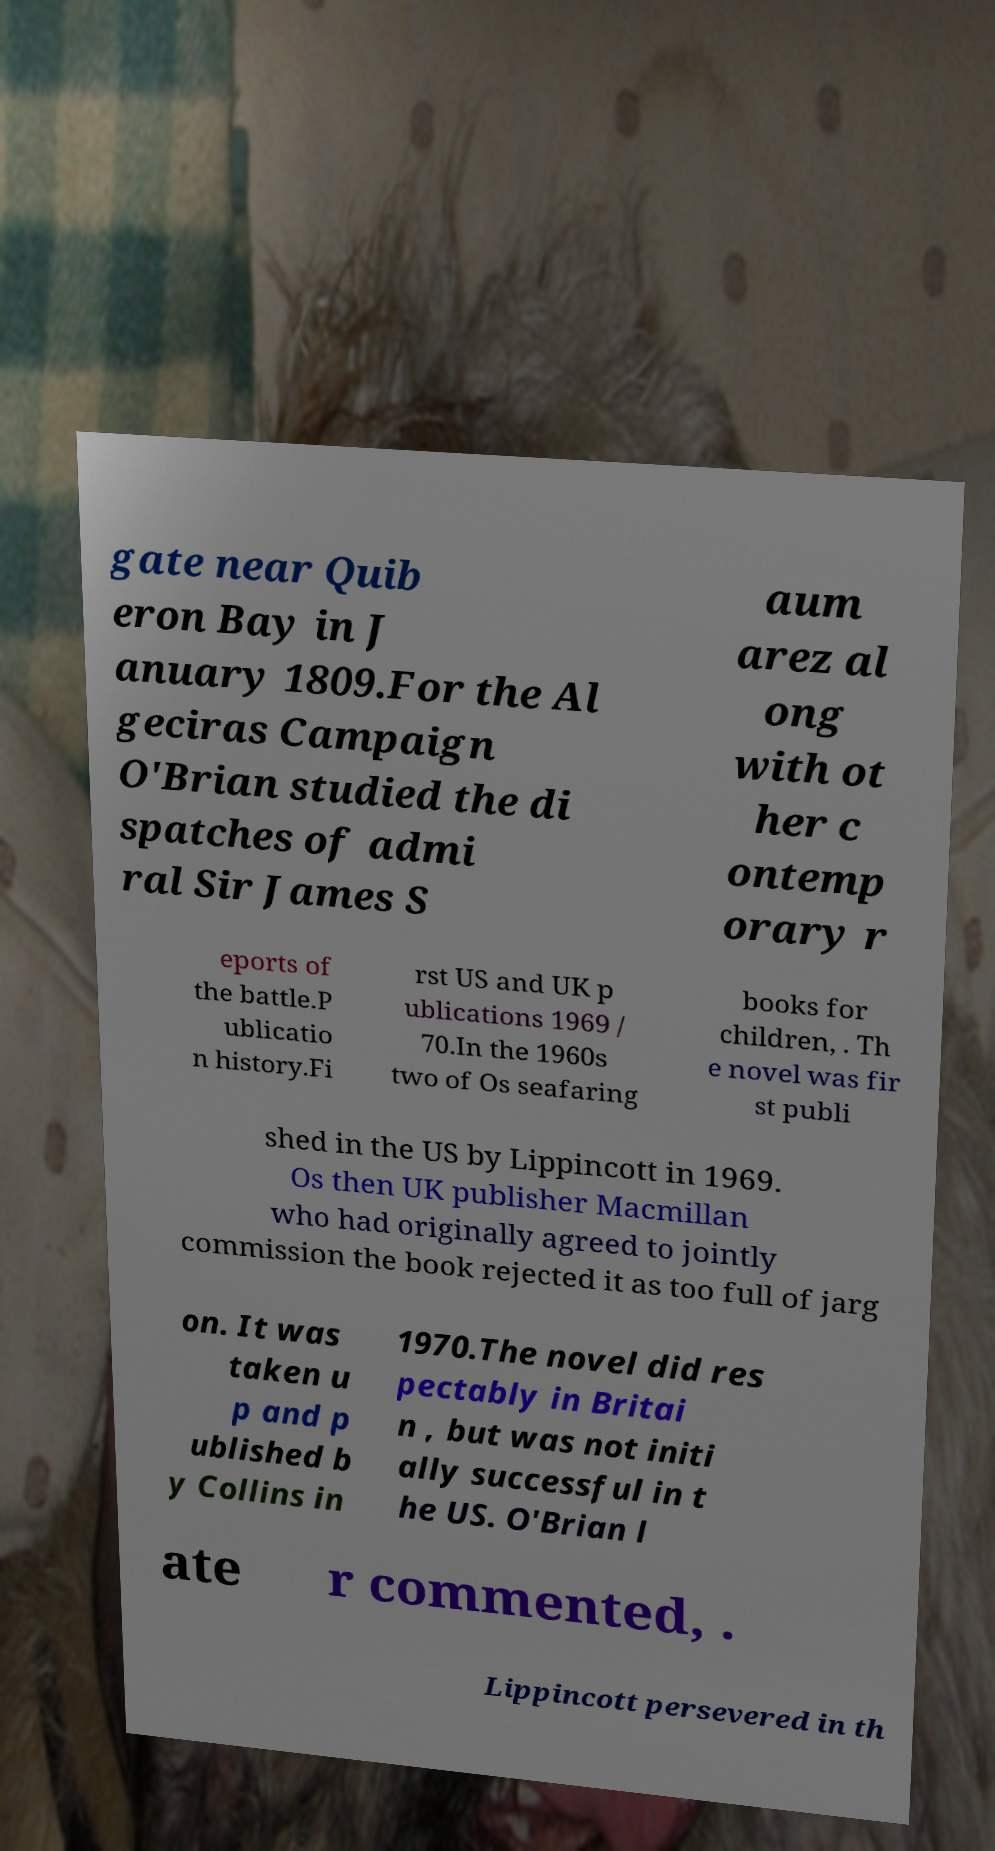Could you assist in decoding the text presented in this image and type it out clearly? gate near Quib eron Bay in J anuary 1809.For the Al geciras Campaign O'Brian studied the di spatches of admi ral Sir James S aum arez al ong with ot her c ontemp orary r eports of the battle.P ublicatio n history.Fi rst US and UK p ublications 1969 / 70.In the 1960s two of Os seafaring books for children, . Th e novel was fir st publi shed in the US by Lippincott in 1969. Os then UK publisher Macmillan who had originally agreed to jointly commission the book rejected it as too full of jarg on. It was taken u p and p ublished b y Collins in 1970.The novel did res pectably in Britai n , but was not initi ally successful in t he US. O'Brian l ate r commented, . Lippincott persevered in th 